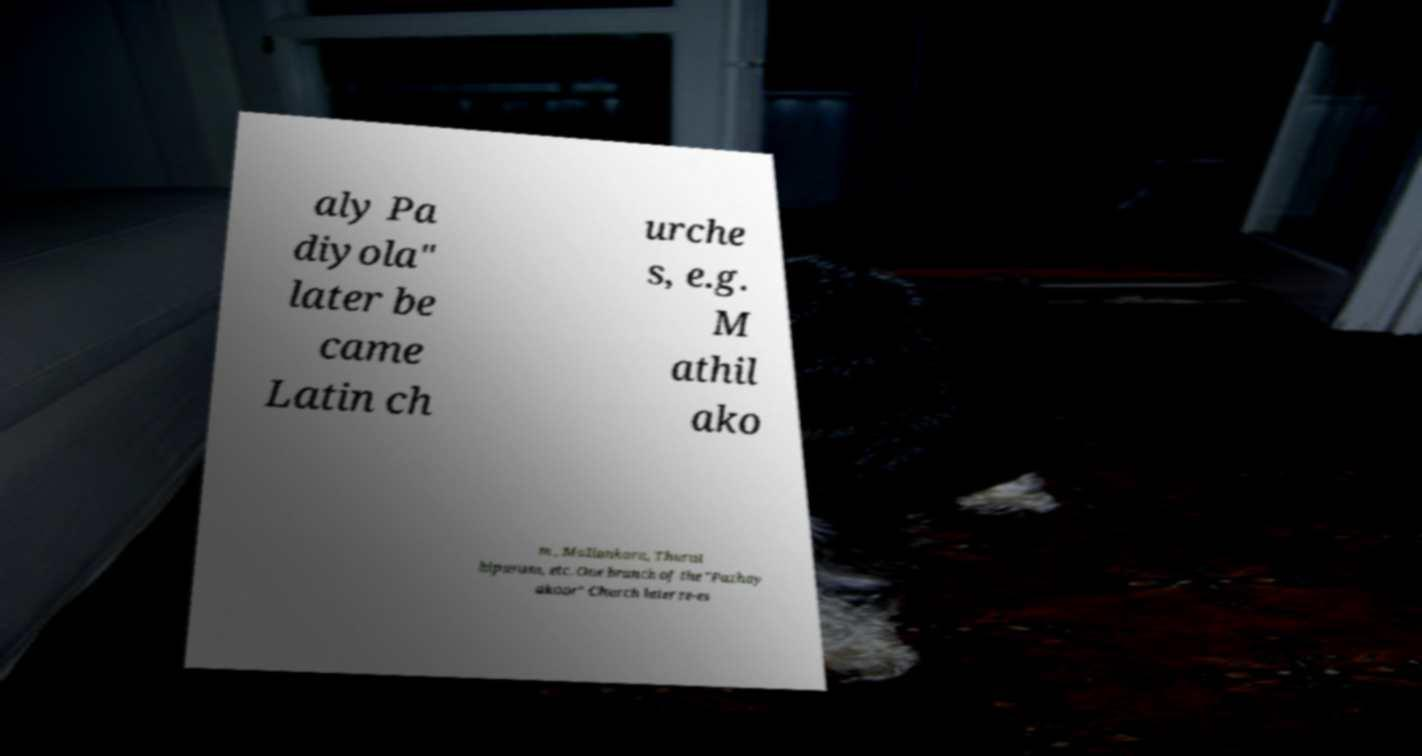Could you assist in decoding the text presented in this image and type it out clearly? aly Pa diyola" later be came Latin ch urche s, e.g. M athil ako m , Maliankara, Thurut hipuram, etc. One branch of the "Pazhay akoor" Church later re-es 